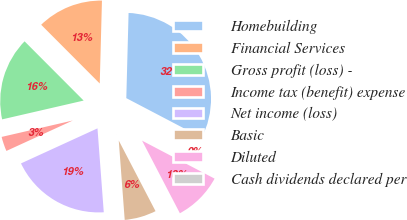Convert chart to OTSL. <chart><loc_0><loc_0><loc_500><loc_500><pie_chart><fcel>Homebuilding<fcel>Financial Services<fcel>Gross profit (loss) -<fcel>Income tax (benefit) expense<fcel>Net income (loss)<fcel>Basic<fcel>Diluted<fcel>Cash dividends declared per<nl><fcel>32.25%<fcel>12.9%<fcel>16.13%<fcel>3.23%<fcel>19.35%<fcel>6.45%<fcel>9.68%<fcel>0.0%<nl></chart> 